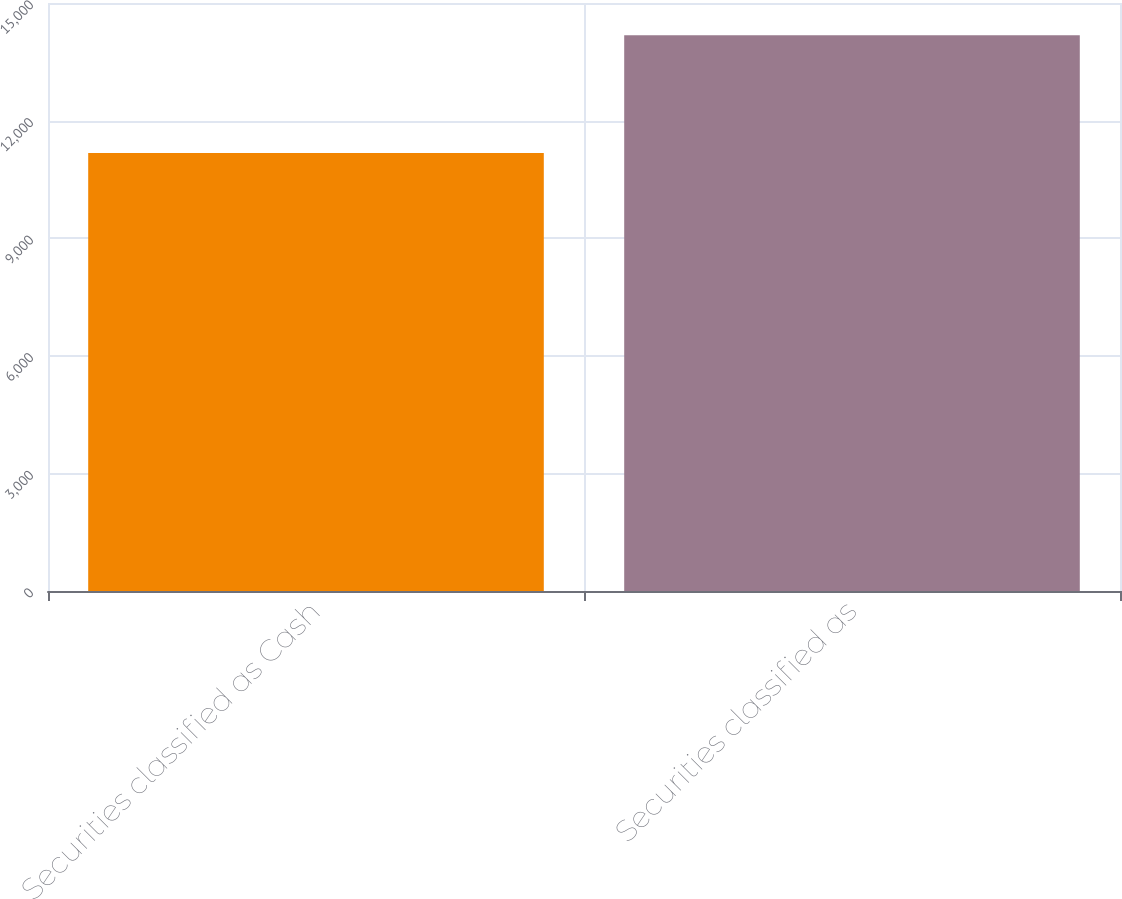Convert chart to OTSL. <chart><loc_0><loc_0><loc_500><loc_500><bar_chart><fcel>Securities classified as Cash<fcel>Securities classified as<nl><fcel>11176<fcel>14178<nl></chart> 